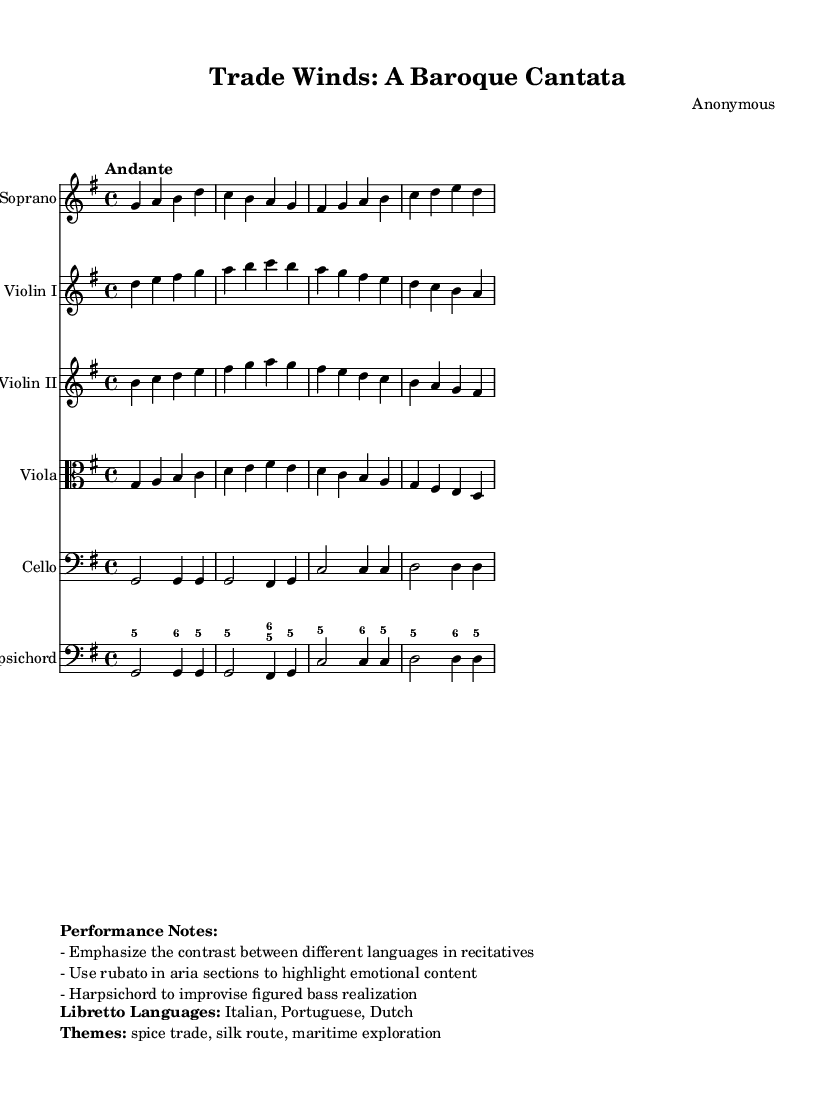What is the key signature of this music? The key signature is G major, which has one sharp (F sharp).
Answer: G major What is the time signature of this music? The time signature is 4/4, indicating four beats per measure.
Answer: 4/4 What is the tempo marking indicated in the sheet music? The tempo marking is "Andante," which signifies a moderately slow pace.
Answer: Andante How many instruments are included in this score? There are six instruments specified in the score: Soprano, Violin I, Violin II, Viola, Cello, and Harpsichord.
Answer: Six What languages are used in the libretto? The libretto includes Italian, Portuguese, and Dutch, reflecting the influences of international commerce.
Answer: Italian, Portuguese, Dutch What themes are highlighted in the cantata's libretto? The themes are the spice trade, silk route, and maritime exploration, which are historically significant in trade interactions.
Answer: Spice trade, silk route, maritime exploration What performance note emphasizes emotional contrast? The performance note specifies to "Emphasize the contrast between different languages in recitatives."
Answer: Contrast in recitatives 